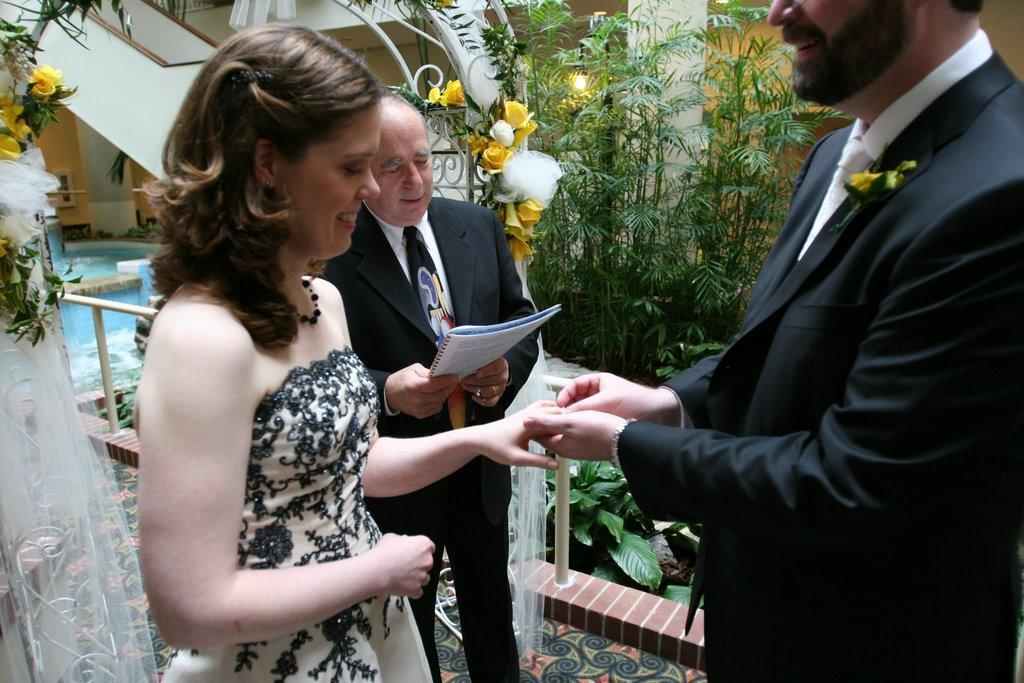How many people are in the image? There are three persons in the image. What is one of the persons holding? One of the persons is holding a book. What type of vegetation can be seen in the image? There are plants and flowers in the image. What architectural feature is present in the image? There are poles in the image. What type of structure is visible in the image? There is a house in the image. What natural element is visible in the image? There is water visible in the image. What source of illumination is present in the image? There is a light in the image. What type of vase is holding the bread in the image? There is no vase or bread present in the image. How many hens are visible in the image? There are no hens visible in the image. 